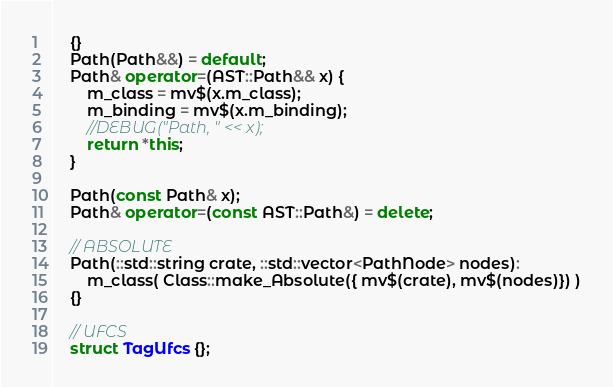Convert code to text. <code><loc_0><loc_0><loc_500><loc_500><_C++_>    {}
    Path(Path&&) = default;
    Path& operator=(AST::Path&& x) {
        m_class = mv$(x.m_class);
        m_binding = mv$(x.m_binding);
        //DEBUG("Path, " << x);
        return *this;
    }

    Path(const Path& x);
    Path& operator=(const AST::Path&) = delete;

    // ABSOLUTE
    Path(::std::string crate, ::std::vector<PathNode> nodes):
        m_class( Class::make_Absolute({ mv$(crate), mv$(nodes)}) )
    {}

    // UFCS
    struct TagUfcs {};</code> 